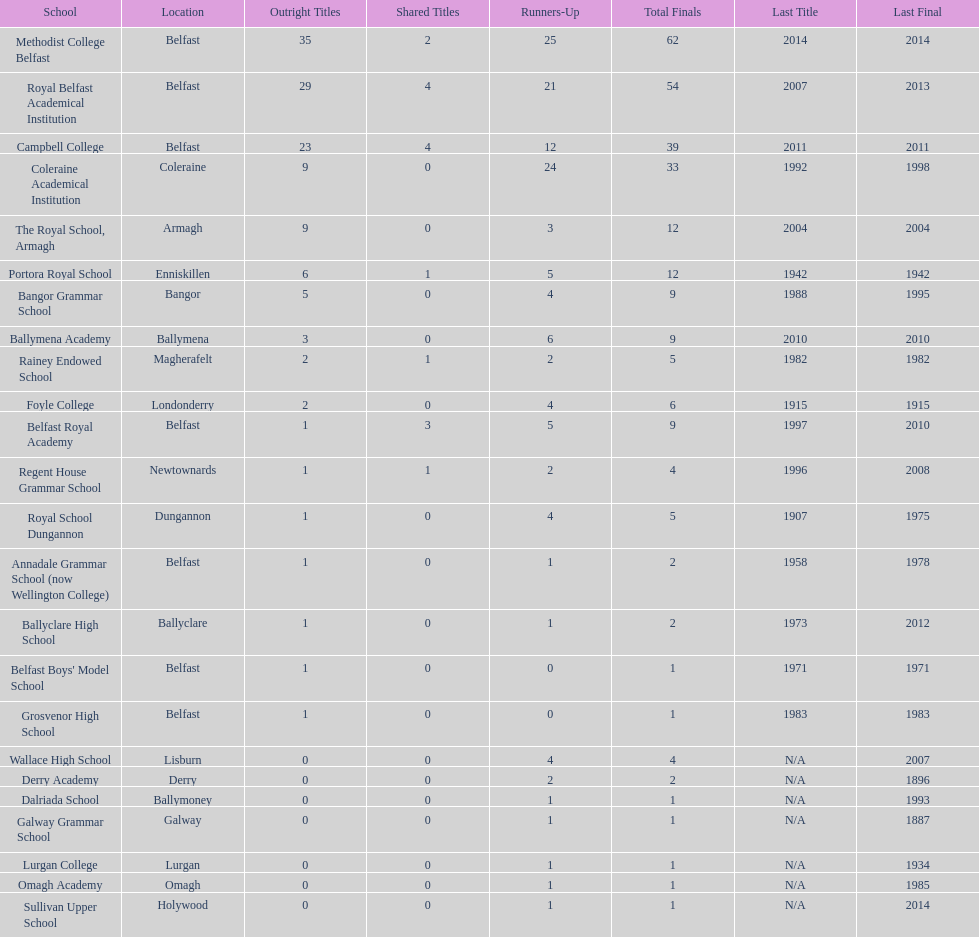Can you give me this table as a dict? {'header': ['School', 'Location', 'Outright Titles', 'Shared Titles', 'Runners-Up', 'Total Finals', 'Last Title', 'Last Final'], 'rows': [['Methodist College Belfast', 'Belfast', '35', '2', '25', '62', '2014', '2014'], ['Royal Belfast Academical Institution', 'Belfast', '29', '4', '21', '54', '2007', '2013'], ['Campbell College', 'Belfast', '23', '4', '12', '39', '2011', '2011'], ['Coleraine Academical Institution', 'Coleraine', '9', '0', '24', '33', '1992', '1998'], ['The Royal School, Armagh', 'Armagh', '9', '0', '3', '12', '2004', '2004'], ['Portora Royal School', 'Enniskillen', '6', '1', '5', '12', '1942', '1942'], ['Bangor Grammar School', 'Bangor', '5', '0', '4', '9', '1988', '1995'], ['Ballymena Academy', 'Ballymena', '3', '0', '6', '9', '2010', '2010'], ['Rainey Endowed School', 'Magherafelt', '2', '1', '2', '5', '1982', '1982'], ['Foyle College', 'Londonderry', '2', '0', '4', '6', '1915', '1915'], ['Belfast Royal Academy', 'Belfast', '1', '3', '5', '9', '1997', '2010'], ['Regent House Grammar School', 'Newtownards', '1', '1', '2', '4', '1996', '2008'], ['Royal School Dungannon', 'Dungannon', '1', '0', '4', '5', '1907', '1975'], ['Annadale Grammar School (now Wellington College)', 'Belfast', '1', '0', '1', '2', '1958', '1978'], ['Ballyclare High School', 'Ballyclare', '1', '0', '1', '2', '1973', '2012'], ["Belfast Boys' Model School", 'Belfast', '1', '0', '0', '1', '1971', '1971'], ['Grosvenor High School', 'Belfast', '1', '0', '0', '1', '1983', '1983'], ['Wallace High School', 'Lisburn', '0', '0', '4', '4', 'N/A', '2007'], ['Derry Academy', 'Derry', '0', '0', '2', '2', 'N/A', '1896'], ['Dalriada School', 'Ballymoney', '0', '0', '1', '1', 'N/A', '1993'], ['Galway Grammar School', 'Galway', '0', '0', '1', '1', 'N/A', '1887'], ['Lurgan College', 'Lurgan', '0', '0', '1', '1', 'N/A', '1934'], ['Omagh Academy', 'Omagh', '0', '0', '1', '1', 'N/A', '1985'], ['Sullivan Upper School', 'Holywood', '0', '0', '1', '1', 'N/A', '2014']]} Which two institutions each had twelve overall finals? The Royal School, Armagh, Portora Royal School. 